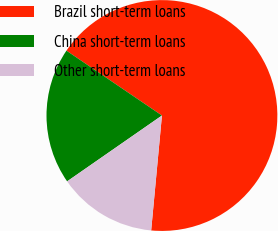<chart> <loc_0><loc_0><loc_500><loc_500><pie_chart><fcel>Brazil short-term loans<fcel>China short-term loans<fcel>Other short-term loans<nl><fcel>66.99%<fcel>19.16%<fcel>13.85%<nl></chart> 